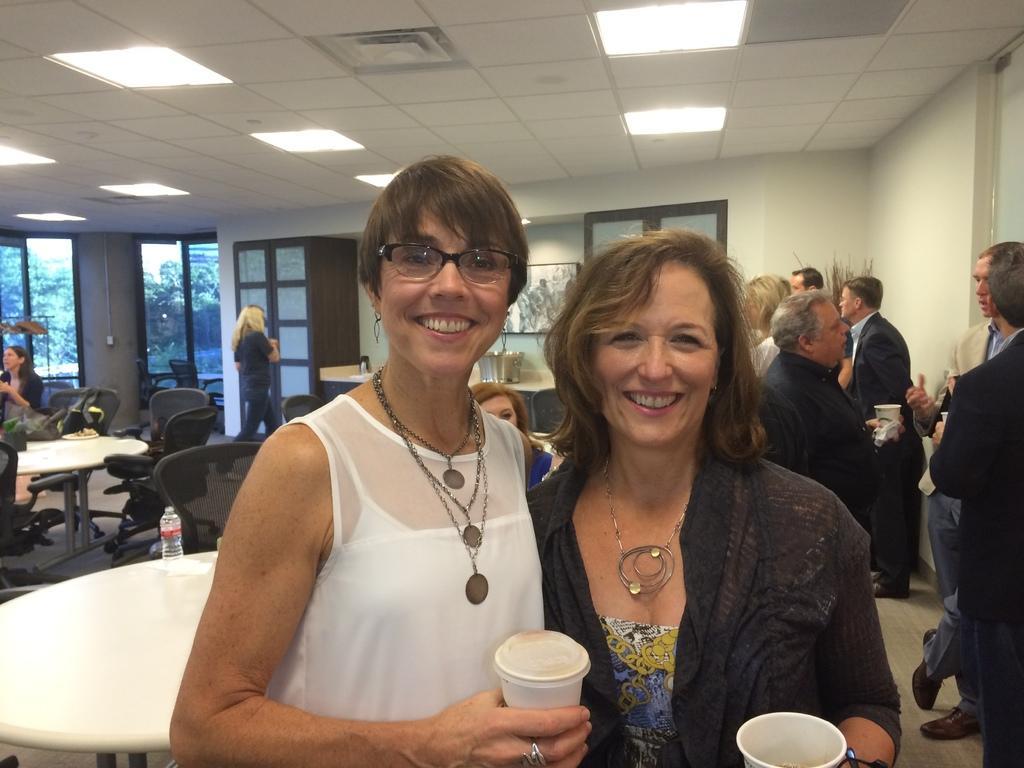Please provide a concise description of this image. In this image I can see two women wearing white and black colored dresses are standing and holding cups in their hands. In the background I can see few tables, few chairs, a bottle on the table, the wall, a frame attached to the wall, few persons standing, few persons sitting, the ceiling, few lights to the ceiling and the glass windows through which I can see few trees and the sky. 